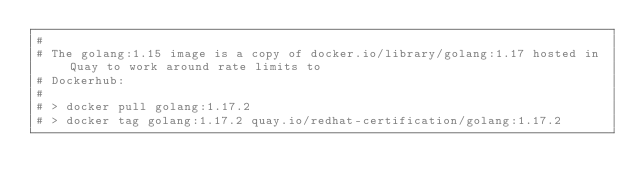Convert code to text. <code><loc_0><loc_0><loc_500><loc_500><_Dockerfile_>#
# The golang:1.15 image is a copy of docker.io/library/golang:1.17 hosted in Quay to work around rate limits to
# Dockerhub:
#
# > docker pull golang:1.17.2
# > docker tag golang:1.17.2 quay.io/redhat-certification/golang:1.17.2</code> 